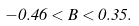Convert formula to latex. <formula><loc_0><loc_0><loc_500><loc_500>- 0 . 4 6 < B < 0 . 3 5 .</formula> 